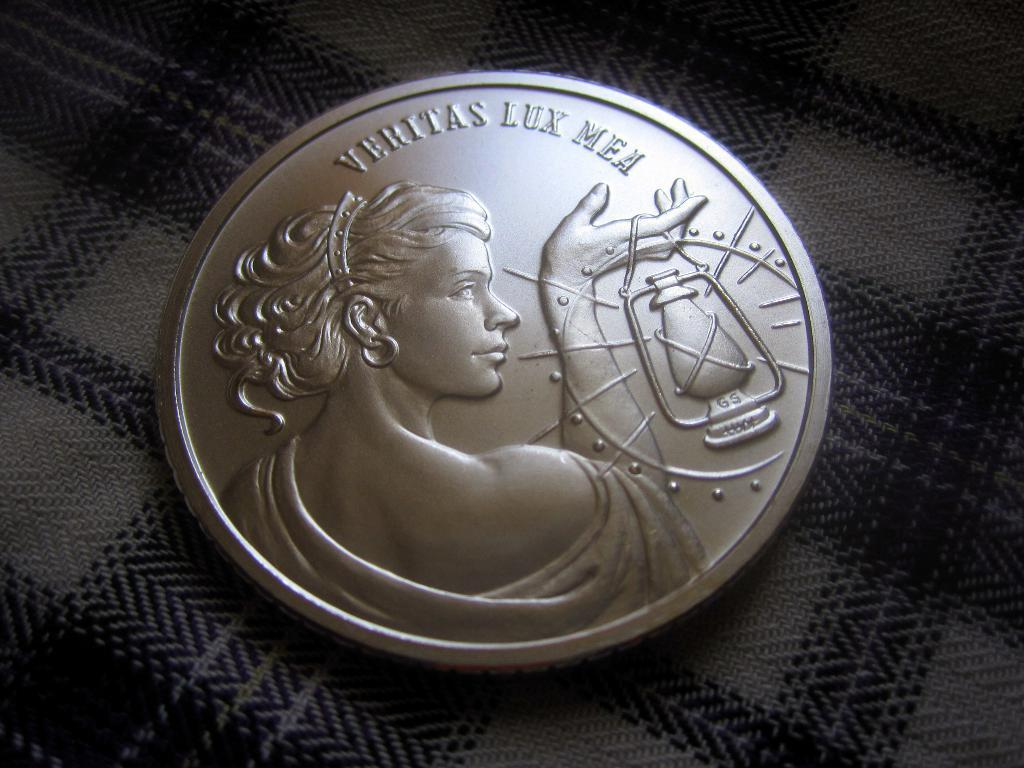<image>
Render a clear and concise summary of the photo. A coin is stamped with the phrase veritas lux mea and has a woman on it. 